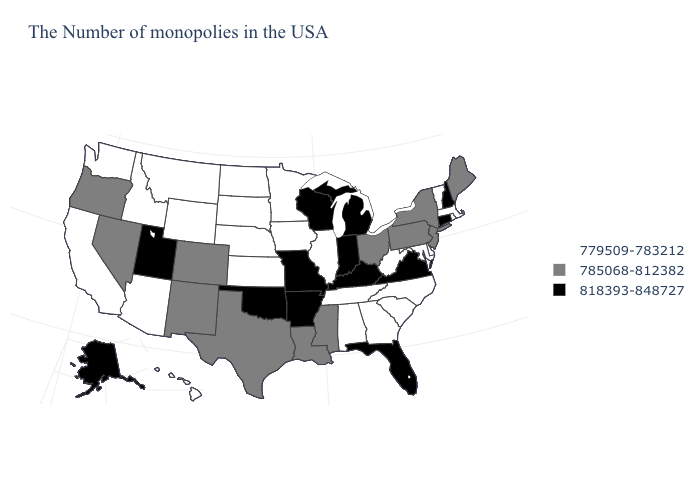What is the value of Maine?
Answer briefly. 785068-812382. Name the states that have a value in the range 818393-848727?
Concise answer only. New Hampshire, Connecticut, Virginia, Florida, Michigan, Kentucky, Indiana, Wisconsin, Missouri, Arkansas, Oklahoma, Utah, Alaska. Which states hav the highest value in the Northeast?
Quick response, please. New Hampshire, Connecticut. Does Massachusetts have the lowest value in the Northeast?
Quick response, please. Yes. Which states have the lowest value in the West?
Give a very brief answer. Wyoming, Montana, Arizona, Idaho, California, Washington, Hawaii. What is the value of Michigan?
Write a very short answer. 818393-848727. Name the states that have a value in the range 818393-848727?
Concise answer only. New Hampshire, Connecticut, Virginia, Florida, Michigan, Kentucky, Indiana, Wisconsin, Missouri, Arkansas, Oklahoma, Utah, Alaska. What is the value of Nevada?
Concise answer only. 785068-812382. Does Maine have the lowest value in the USA?
Write a very short answer. No. What is the value of Mississippi?
Give a very brief answer. 785068-812382. What is the value of Pennsylvania?
Answer briefly. 785068-812382. Does Maine have the same value as Vermont?
Short answer required. No. What is the value of Nevada?
Short answer required. 785068-812382. What is the value of Florida?
Quick response, please. 818393-848727. What is the highest value in the MidWest ?
Short answer required. 818393-848727. 